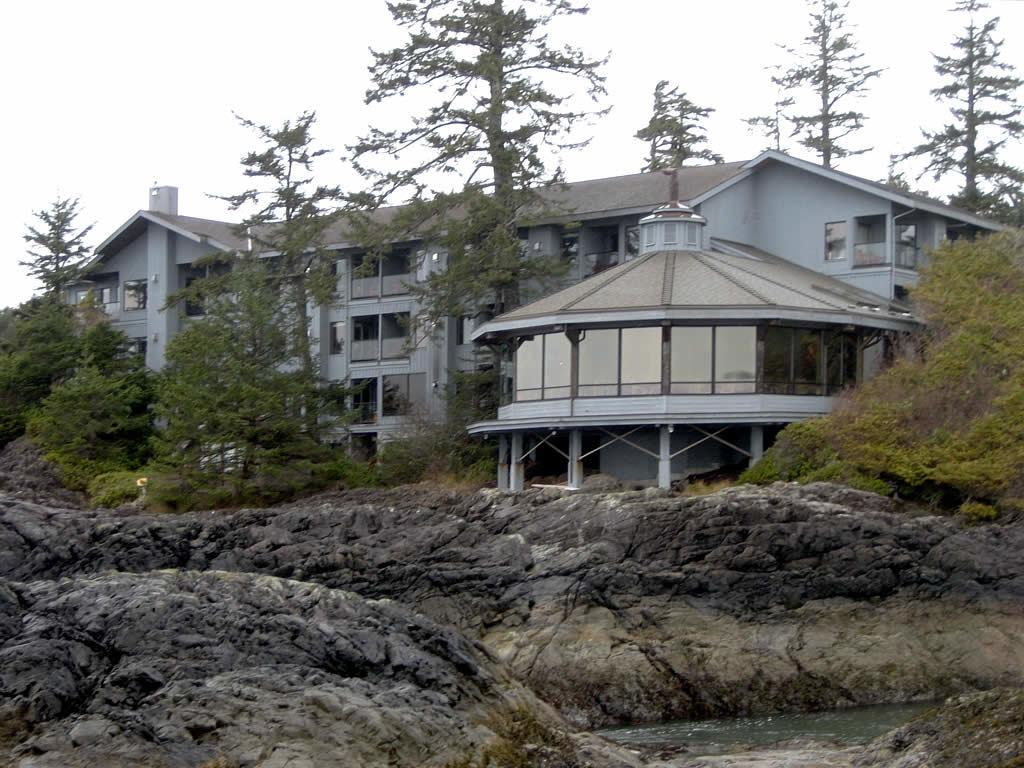What type of structure is visible in the image? There is a building in the image. What architectural features can be seen in the image? There are walls, pillars, and glass objects visible in the image. What natural elements are present in the image? There are trees, plants, rocks, and water at the bottom of the image. What can be seen in the background of the image? The sky is visible in the background of the image. What type of cherry is being used as a decoration on the building in the image? There is no cherry present in the image; it is a building with architectural and natural elements. 